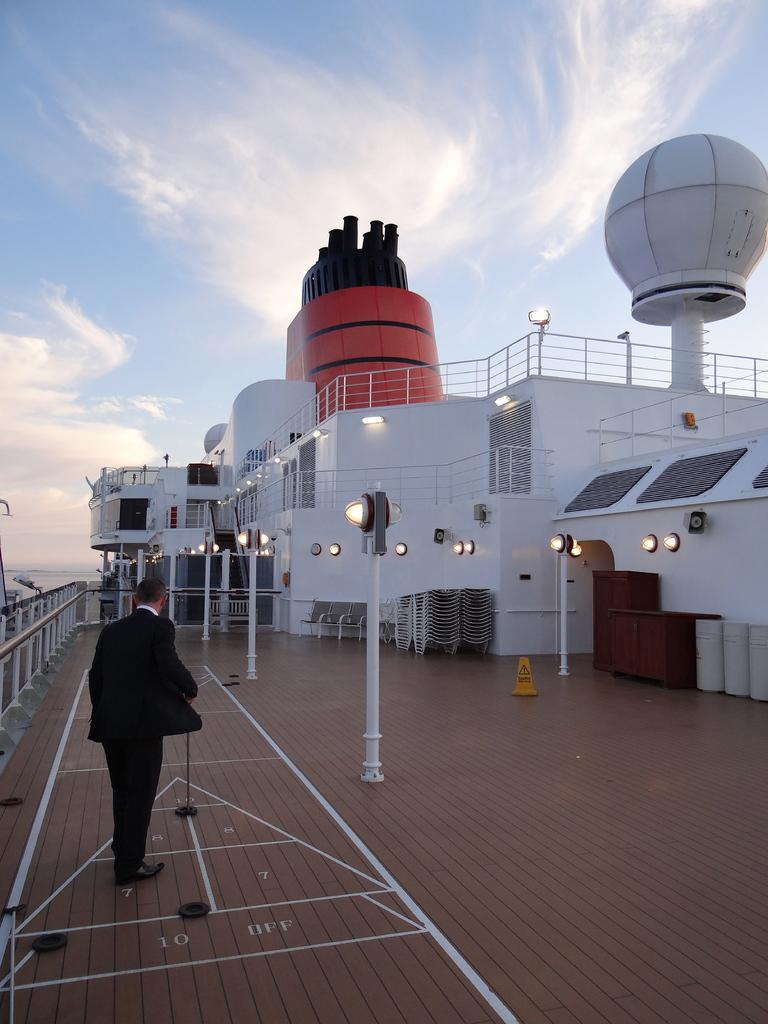What is the main subject in the foreground of the image? There is a man on the boat surface in the foreground of the image. What can be seen in the background of the image? The boat body, railing, and chairs are visible in the background of the image. What natural elements are present in the image? Water and the sky are visible in the image. What is the condition of the sky in the image? Clouds are present in the sky. What is the rate of the match being played on the boat in the image? There is no match being played on the boat in the image. The image features a man on the boat surface and the boat's features in the background, but no sporting event is taking place. 